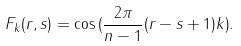<formula> <loc_0><loc_0><loc_500><loc_500>F _ { k } ( r , s ) = \cos { ( \frac { 2 \pi } { n - 1 } ( r - s + 1 ) k ) } .</formula> 